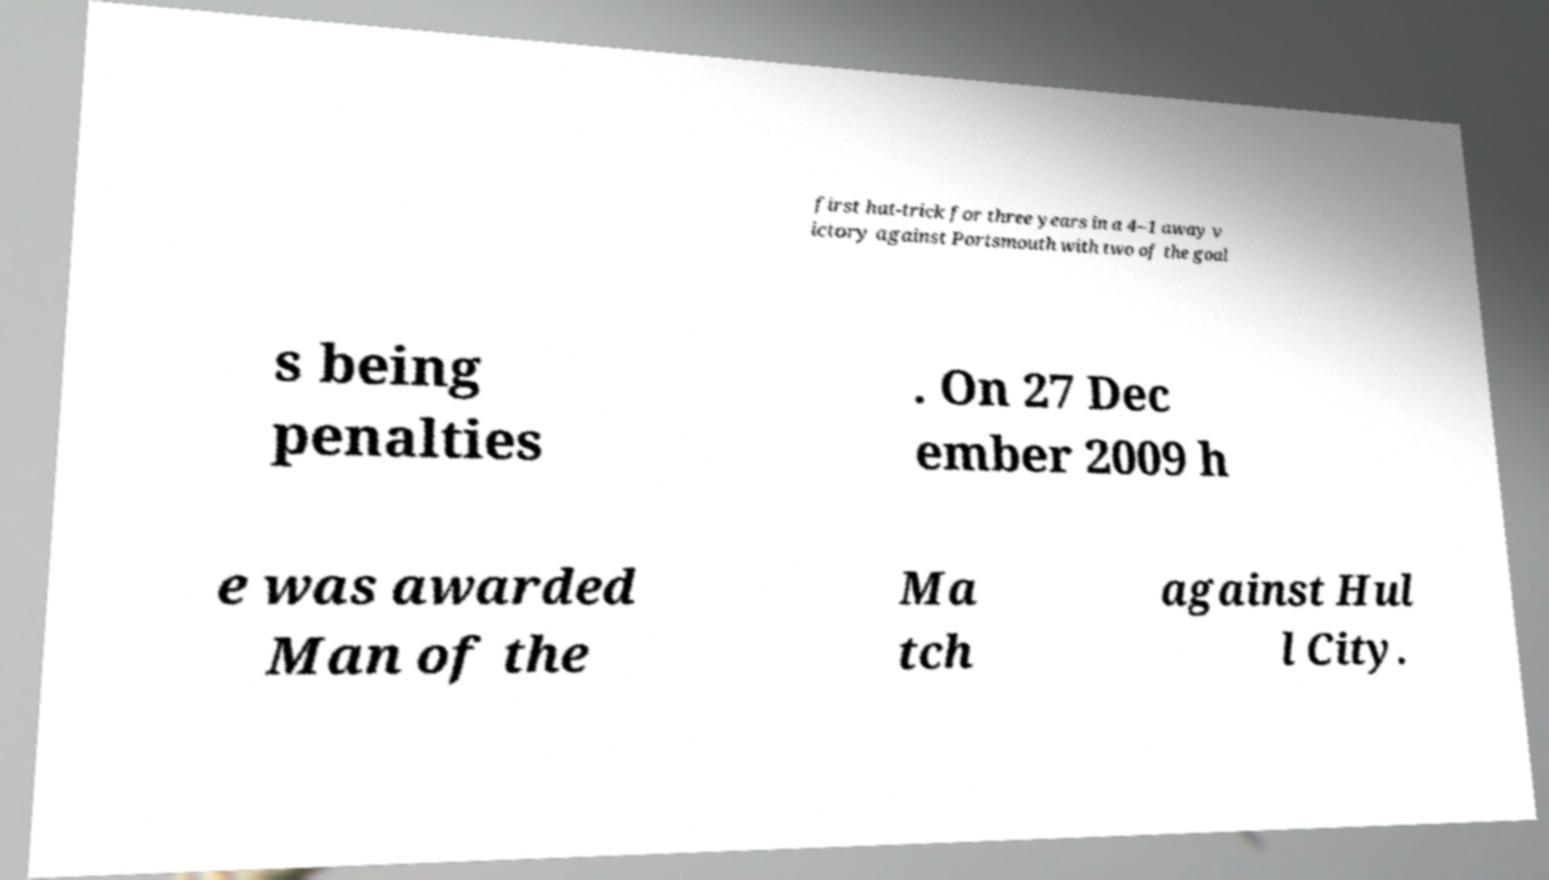Please identify and transcribe the text found in this image. first hat-trick for three years in a 4–1 away v ictory against Portsmouth with two of the goal s being penalties . On 27 Dec ember 2009 h e was awarded Man of the Ma tch against Hul l City. 